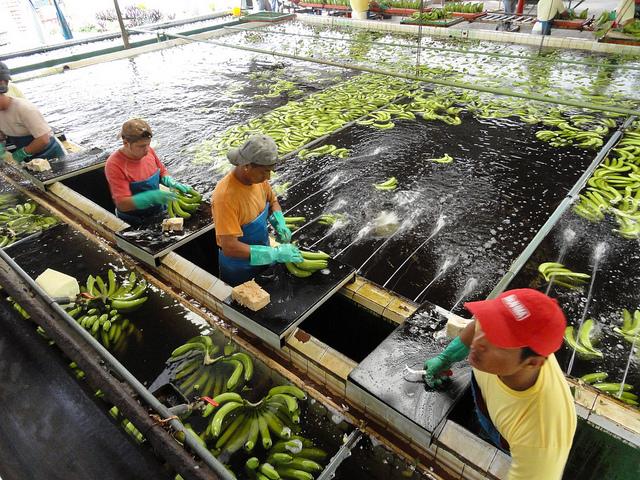How long until the bananas are ripe?
Short answer required. Days. What fruit are they sorting?
Short answer required. Bananas. What type of hand covering are the people wearing?
Give a very brief answer. Gloves. 